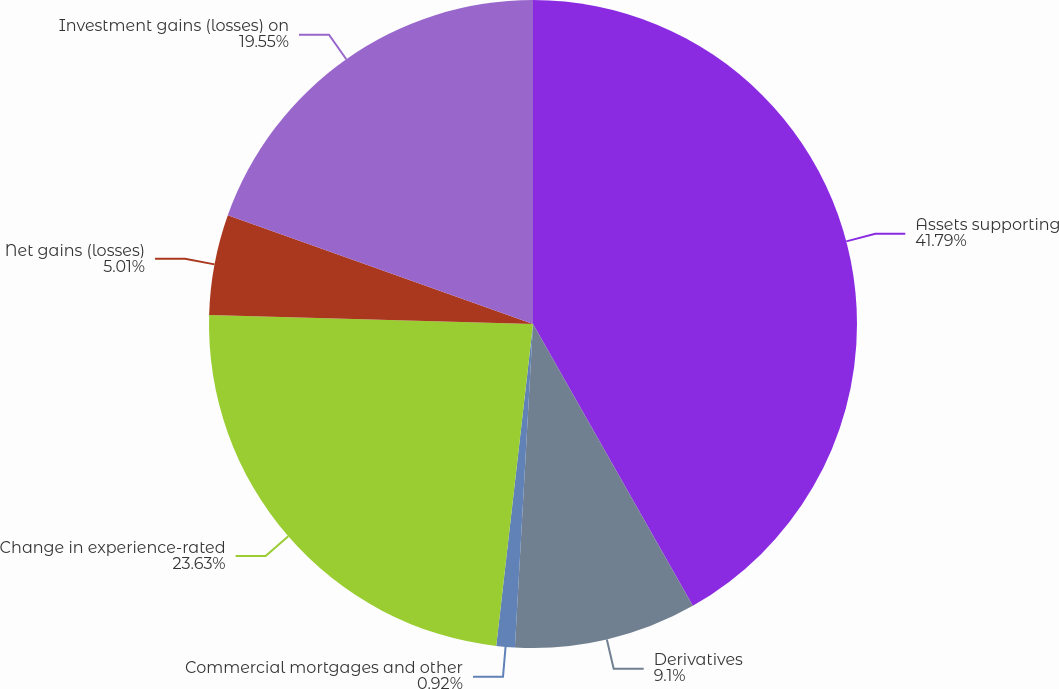<chart> <loc_0><loc_0><loc_500><loc_500><pie_chart><fcel>Assets supporting<fcel>Derivatives<fcel>Commercial mortgages and other<fcel>Change in experience-rated<fcel>Net gains (losses)<fcel>Investment gains (losses) on<nl><fcel>41.79%<fcel>9.1%<fcel>0.92%<fcel>23.63%<fcel>5.01%<fcel>19.55%<nl></chart> 